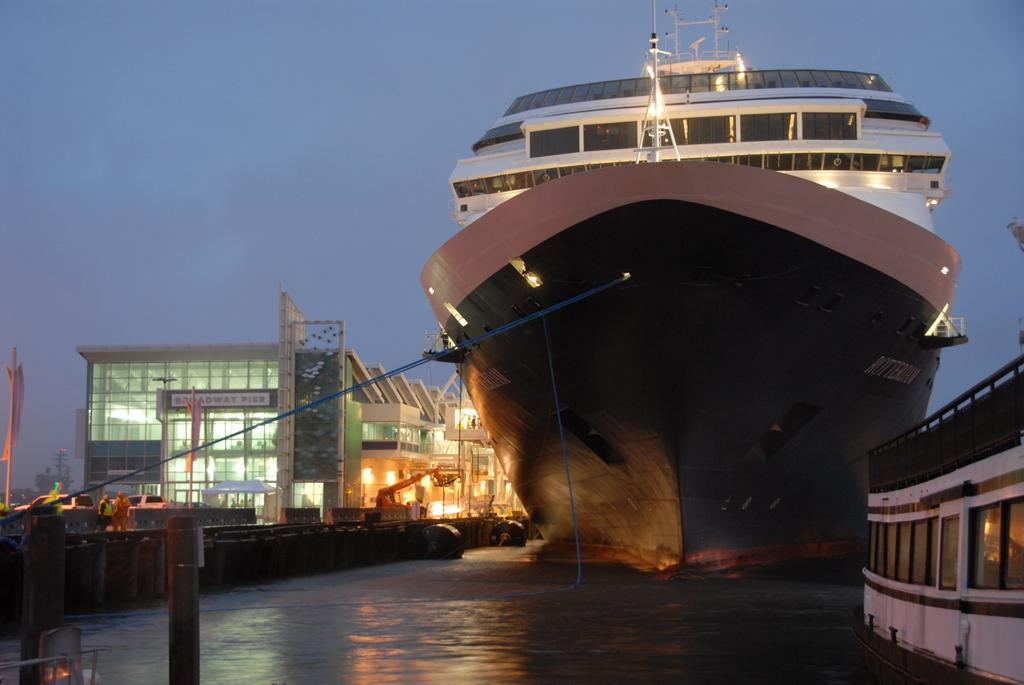<image>
Create a compact narrative representing the image presented. A large cruise ship is docked outside of Broadway Pier 